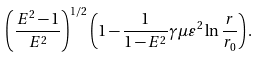<formula> <loc_0><loc_0><loc_500><loc_500>\left ( \frac { E ^ { 2 } - 1 } { E ^ { 2 } } \right ) ^ { 1 / 2 } \left ( 1 - \frac { 1 } { 1 - E ^ { 2 } } \gamma \mu \varepsilon ^ { 2 } \ln \frac { r } { r _ { 0 } } \right ) .</formula> 